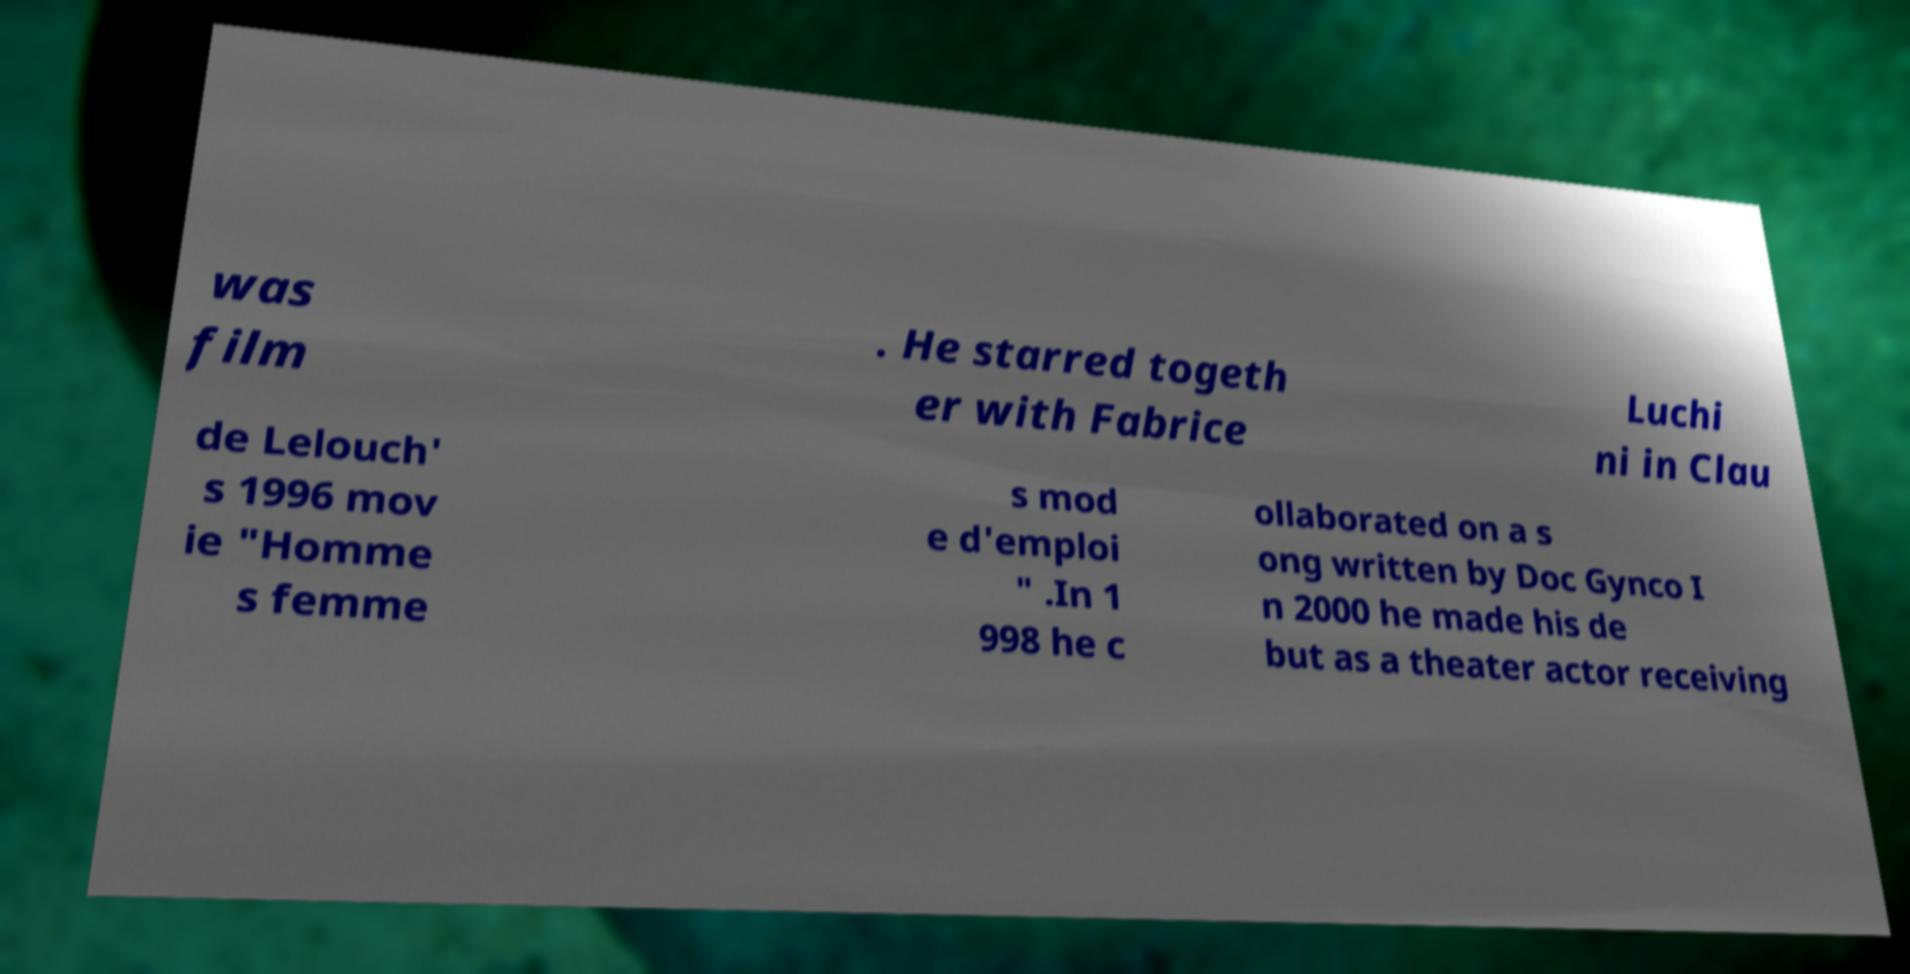Please read and relay the text visible in this image. What does it say? was film . He starred togeth er with Fabrice Luchi ni in Clau de Lelouch' s 1996 mov ie "Homme s femme s mod e d'emploi " .In 1 998 he c ollaborated on a s ong written by Doc Gynco I n 2000 he made his de but as a theater actor receiving 